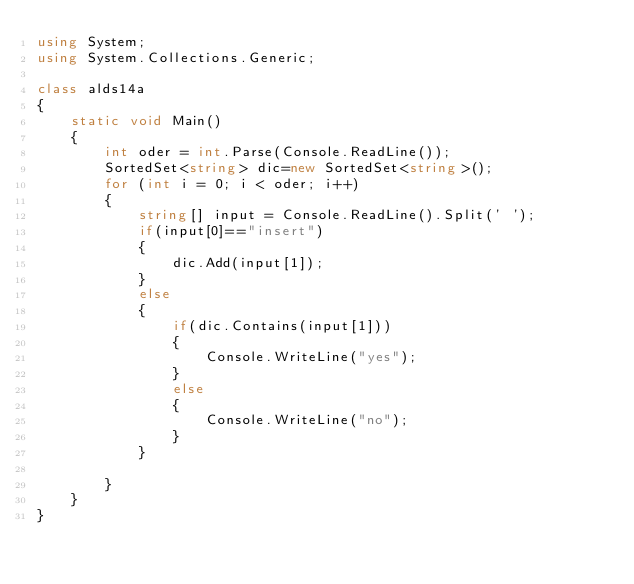Convert code to text. <code><loc_0><loc_0><loc_500><loc_500><_C#_>using System;
using System.Collections.Generic;

class alds14a
{
    static void Main()
    {
        int oder = int.Parse(Console.ReadLine());
        SortedSet<string> dic=new SortedSet<string>();
        for (int i = 0; i < oder; i++)
        {
            string[] input = Console.ReadLine().Split(' ');
            if(input[0]=="insert")
            {
                dic.Add(input[1]);
            }
            else
            {
                if(dic.Contains(input[1]))
                {
                    Console.WriteLine("yes");
                }
                else
                {
                    Console.WriteLine("no");
                }
            }

        }
    }
}</code> 